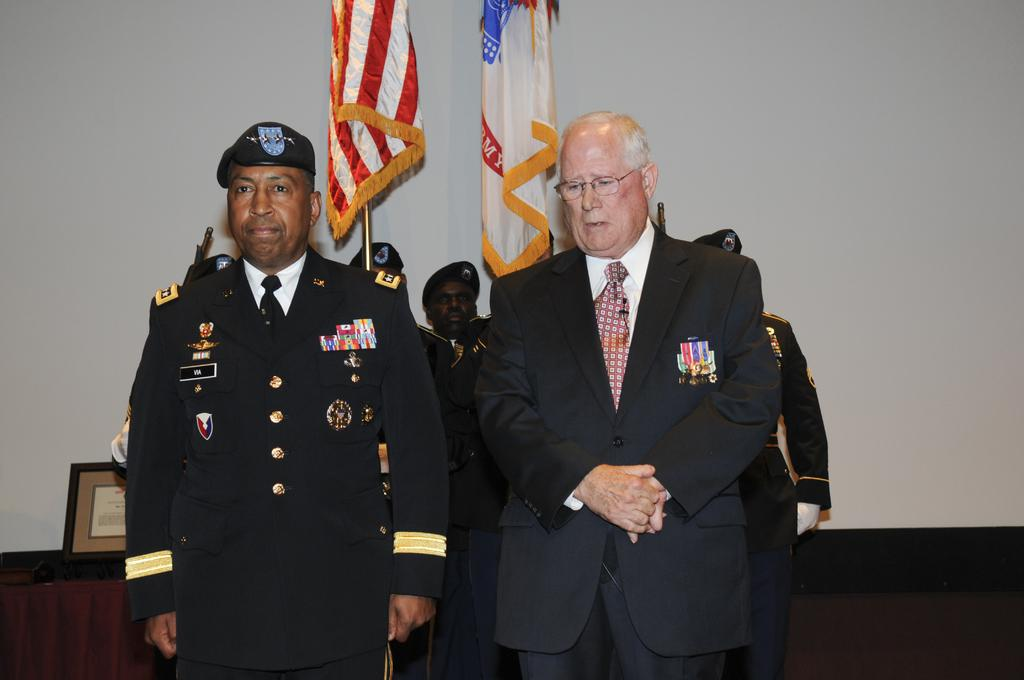What is happening in the image? There are people standing in the image. Can you describe any objects in the image? There are two flags visible in the image. What type of hydrant is providing comfort to the people in the image? There is no hydrant present in the image. What thought is being shared among the people in the image? The image does not provide any information about the thoughts of the people. 